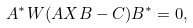<formula> <loc_0><loc_0><loc_500><loc_500>A ^ { * } W ( A X B - C ) B ^ { * } = 0 ,</formula> 